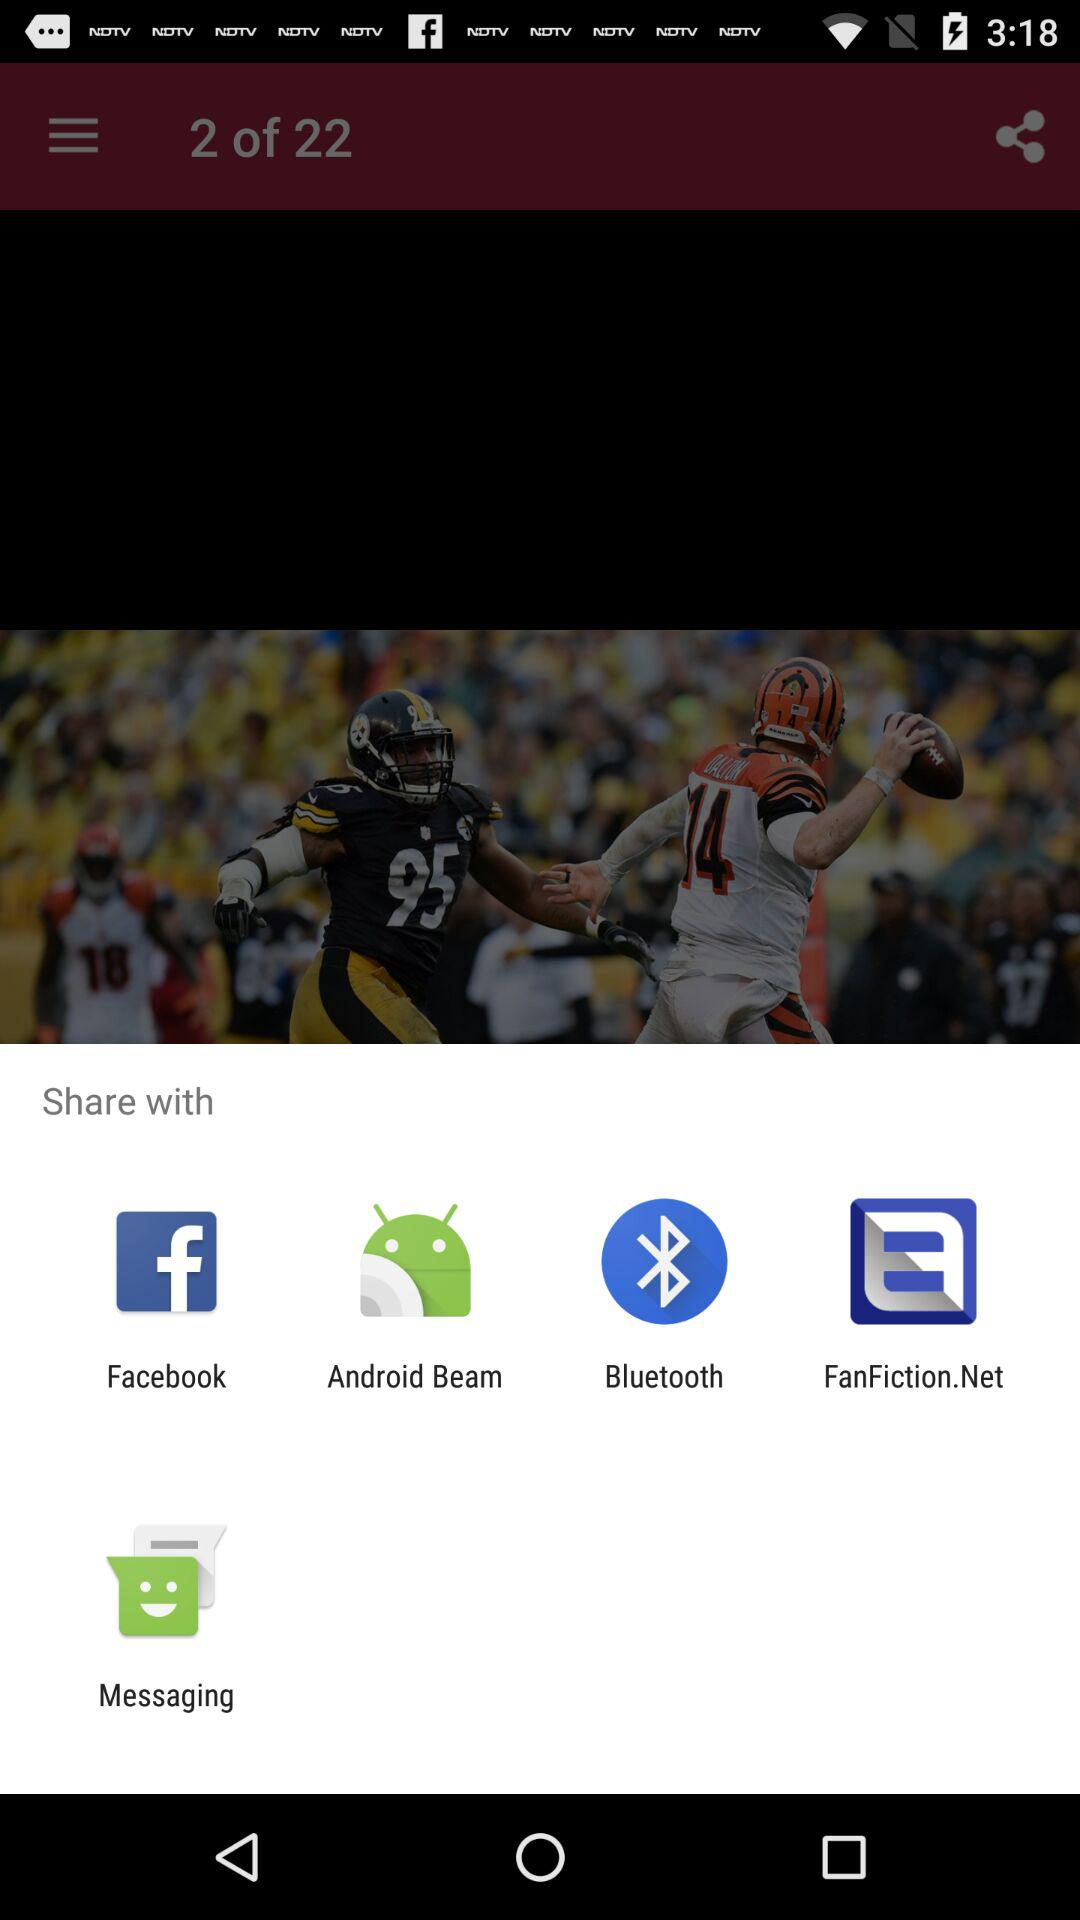How many items are in the share menu? 5 